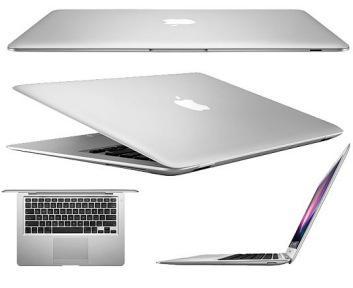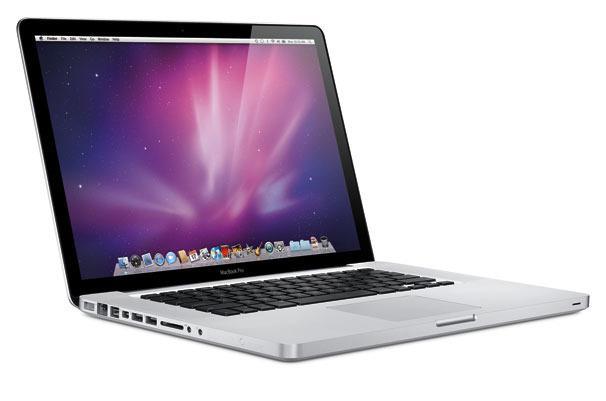The first image is the image on the left, the second image is the image on the right. For the images shown, is this caption "The logo on the back of the laptop is clearly visible in at least one image." true? Answer yes or no. Yes. The first image is the image on the left, the second image is the image on the right. Evaluate the accuracy of this statement regarding the images: "In at least one of the photos, the screen is seen bent in at a sharp angle.". Is it true? Answer yes or no. Yes. 